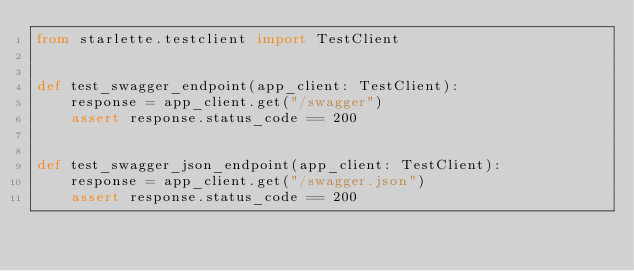<code> <loc_0><loc_0><loc_500><loc_500><_Python_>from starlette.testclient import TestClient


def test_swagger_endpoint(app_client: TestClient):
    response = app_client.get("/swagger")
    assert response.status_code == 200


def test_swagger_json_endpoint(app_client: TestClient):
    response = app_client.get("/swagger.json")
    assert response.status_code == 200
</code> 